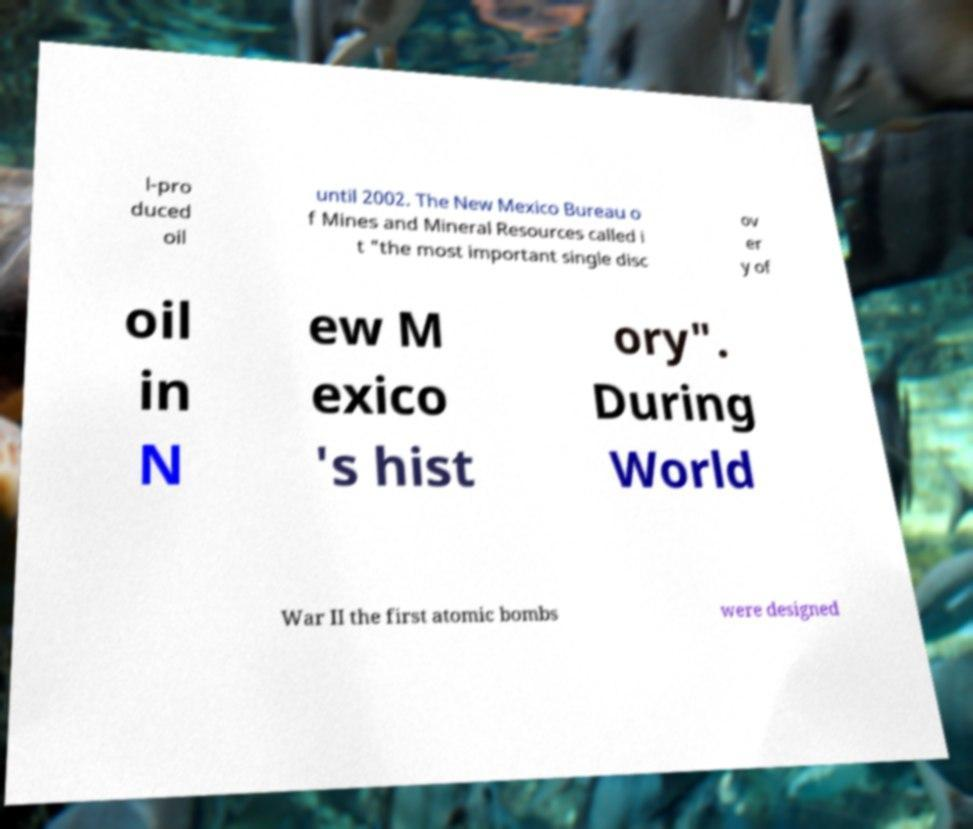Can you read and provide the text displayed in the image?This photo seems to have some interesting text. Can you extract and type it out for me? l-pro duced oil until 2002. The New Mexico Bureau o f Mines and Mineral Resources called i t "the most important single disc ov er y of oil in N ew M exico 's hist ory". During World War II the first atomic bombs were designed 